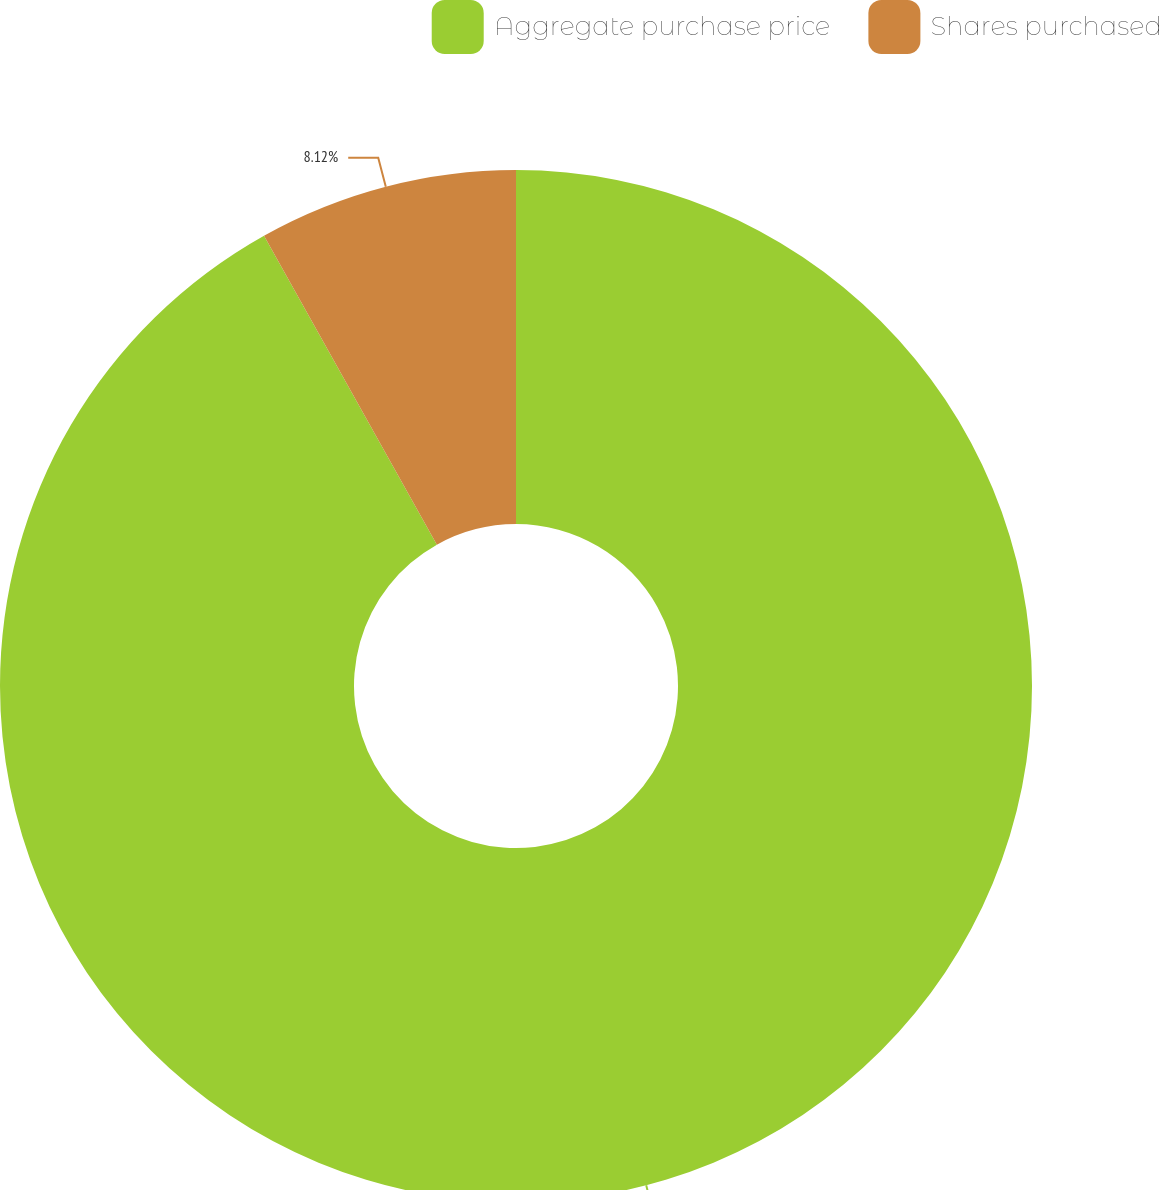<chart> <loc_0><loc_0><loc_500><loc_500><pie_chart><fcel>Aggregate purchase price<fcel>Shares purchased<nl><fcel>91.88%<fcel>8.12%<nl></chart> 